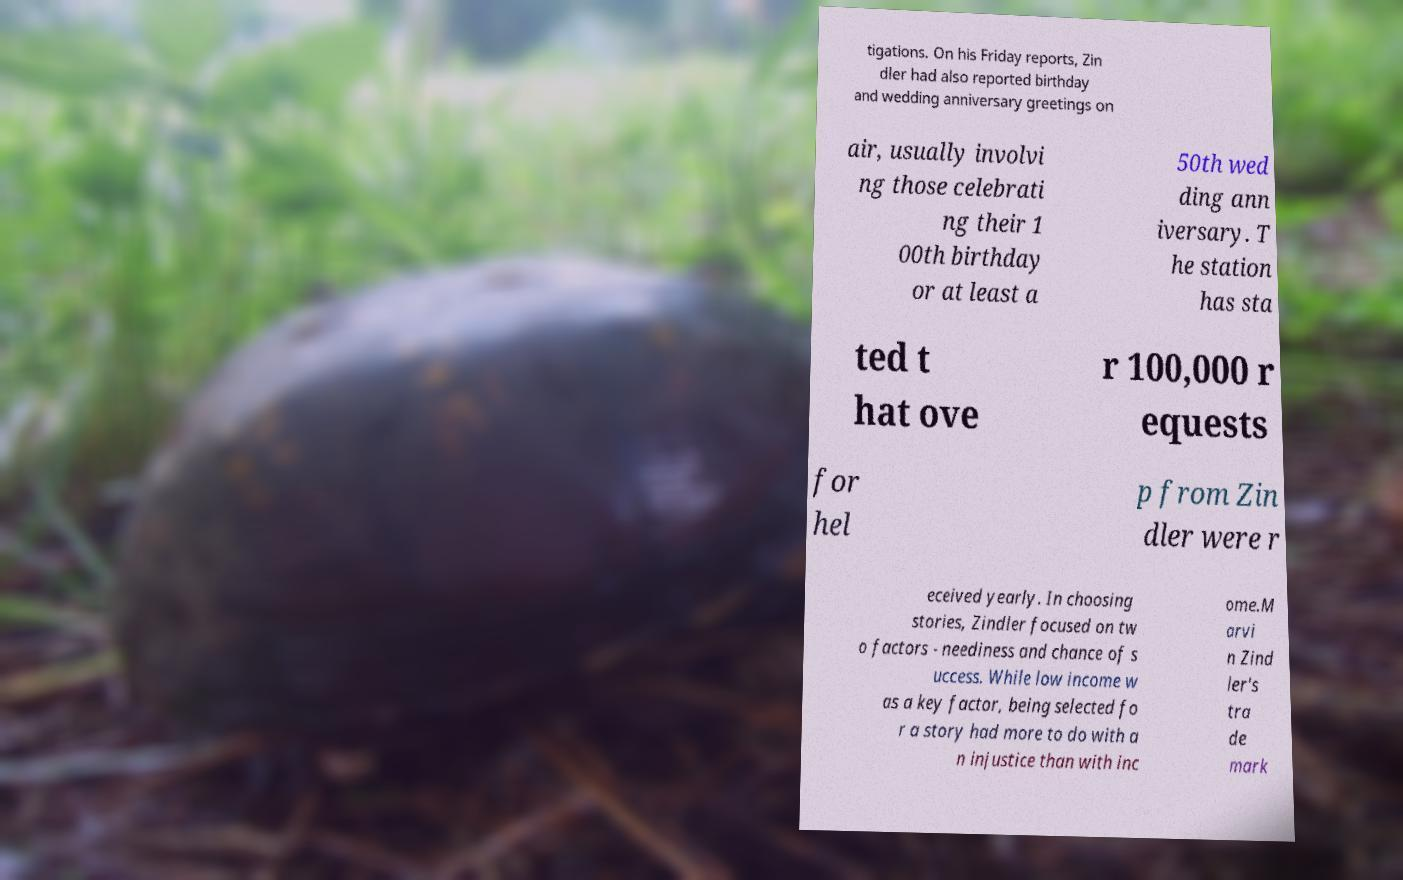Please identify and transcribe the text found in this image. tigations. On his Friday reports, Zin dler had also reported birthday and wedding anniversary greetings on air, usually involvi ng those celebrati ng their 1 00th birthday or at least a 50th wed ding ann iversary. T he station has sta ted t hat ove r 100,000 r equests for hel p from Zin dler were r eceived yearly. In choosing stories, Zindler focused on tw o factors - neediness and chance of s uccess. While low income w as a key factor, being selected fo r a story had more to do with a n injustice than with inc ome.M arvi n Zind ler's tra de mark 